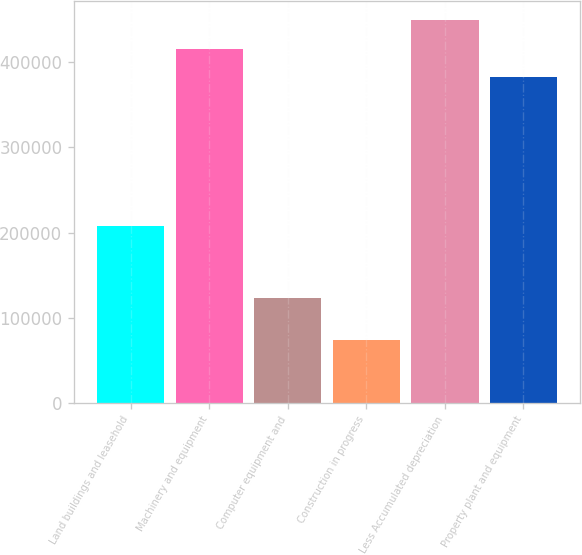<chart> <loc_0><loc_0><loc_500><loc_500><bar_chart><fcel>Land buildings and leasehold<fcel>Machinery and equipment<fcel>Computer equipment and<fcel>Construction in progress<fcel>Less Accumulated depreciation<fcel>Property plant and equipment<nl><fcel>207927<fcel>416252<fcel>122890<fcel>73920<fcel>449505<fcel>382999<nl></chart> 